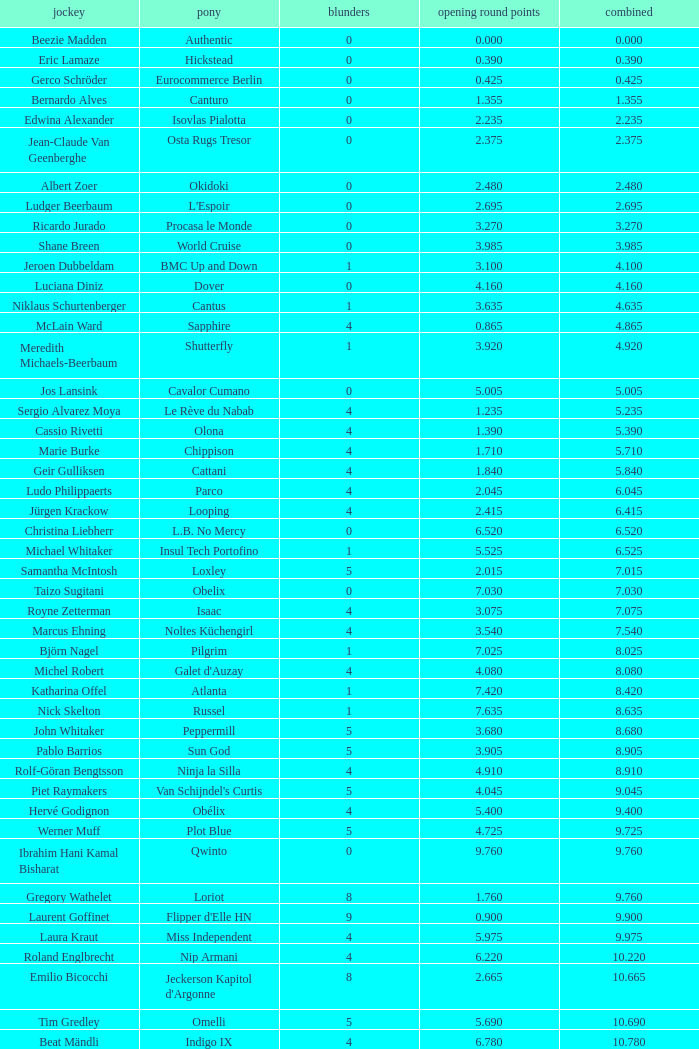Tell me the rider that had round 1 points of 7.465 and total more than 16.615 Manuel Fernandez Saro. 